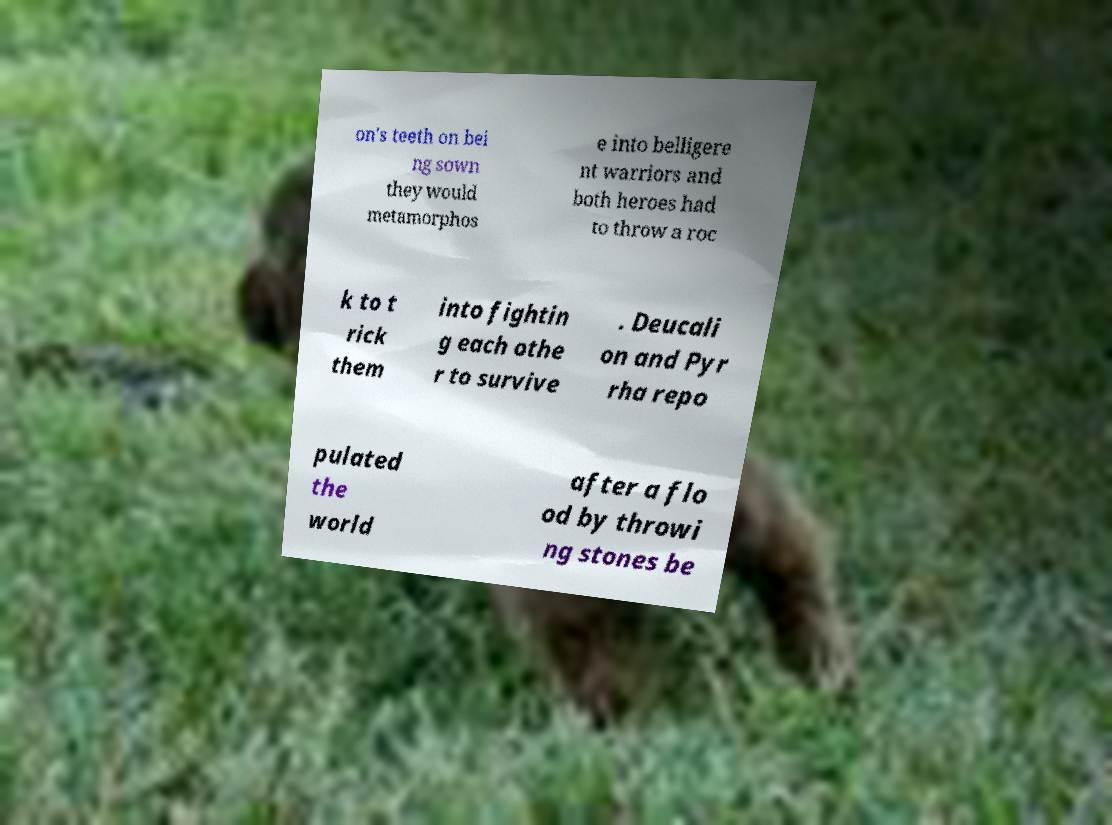Can you read and provide the text displayed in the image?This photo seems to have some interesting text. Can you extract and type it out for me? on's teeth on bei ng sown they would metamorphos e into belligere nt warriors and both heroes had to throw a roc k to t rick them into fightin g each othe r to survive . Deucali on and Pyr rha repo pulated the world after a flo od by throwi ng stones be 